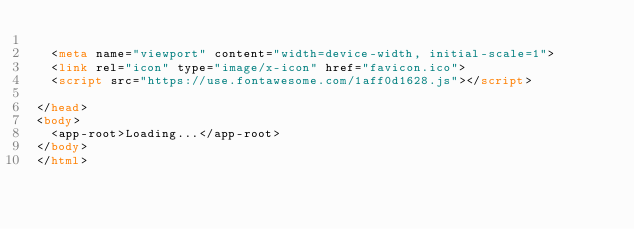Convert code to text. <code><loc_0><loc_0><loc_500><loc_500><_HTML_>
  <meta name="viewport" content="width=device-width, initial-scale=1">
  <link rel="icon" type="image/x-icon" href="favicon.ico">
  <script src="https://use.fontawesome.com/1aff0d1628.js"></script>

</head>
<body>
  <app-root>Loading...</app-root>
</body>
</html>
</code> 